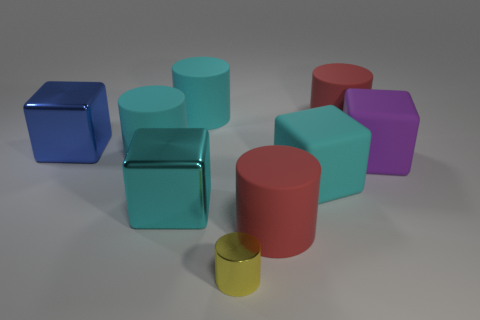How many red cylinders must be subtracted to get 1 red cylinders? 1 Subtract all blue blocks. How many blocks are left? 3 Subtract all tiny shiny cylinders. How many cylinders are left? 4 Subtract 2 cyan cubes. How many objects are left? 7 Subtract all blocks. How many objects are left? 5 Subtract 1 cylinders. How many cylinders are left? 4 Subtract all green cylinders. Subtract all green cubes. How many cylinders are left? 5 Subtract all yellow cubes. How many red cylinders are left? 2 Subtract all large blue metal objects. Subtract all tiny yellow things. How many objects are left? 7 Add 7 red things. How many red things are left? 9 